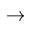<formula> <loc_0><loc_0><loc_500><loc_500>\rightarrow</formula> 